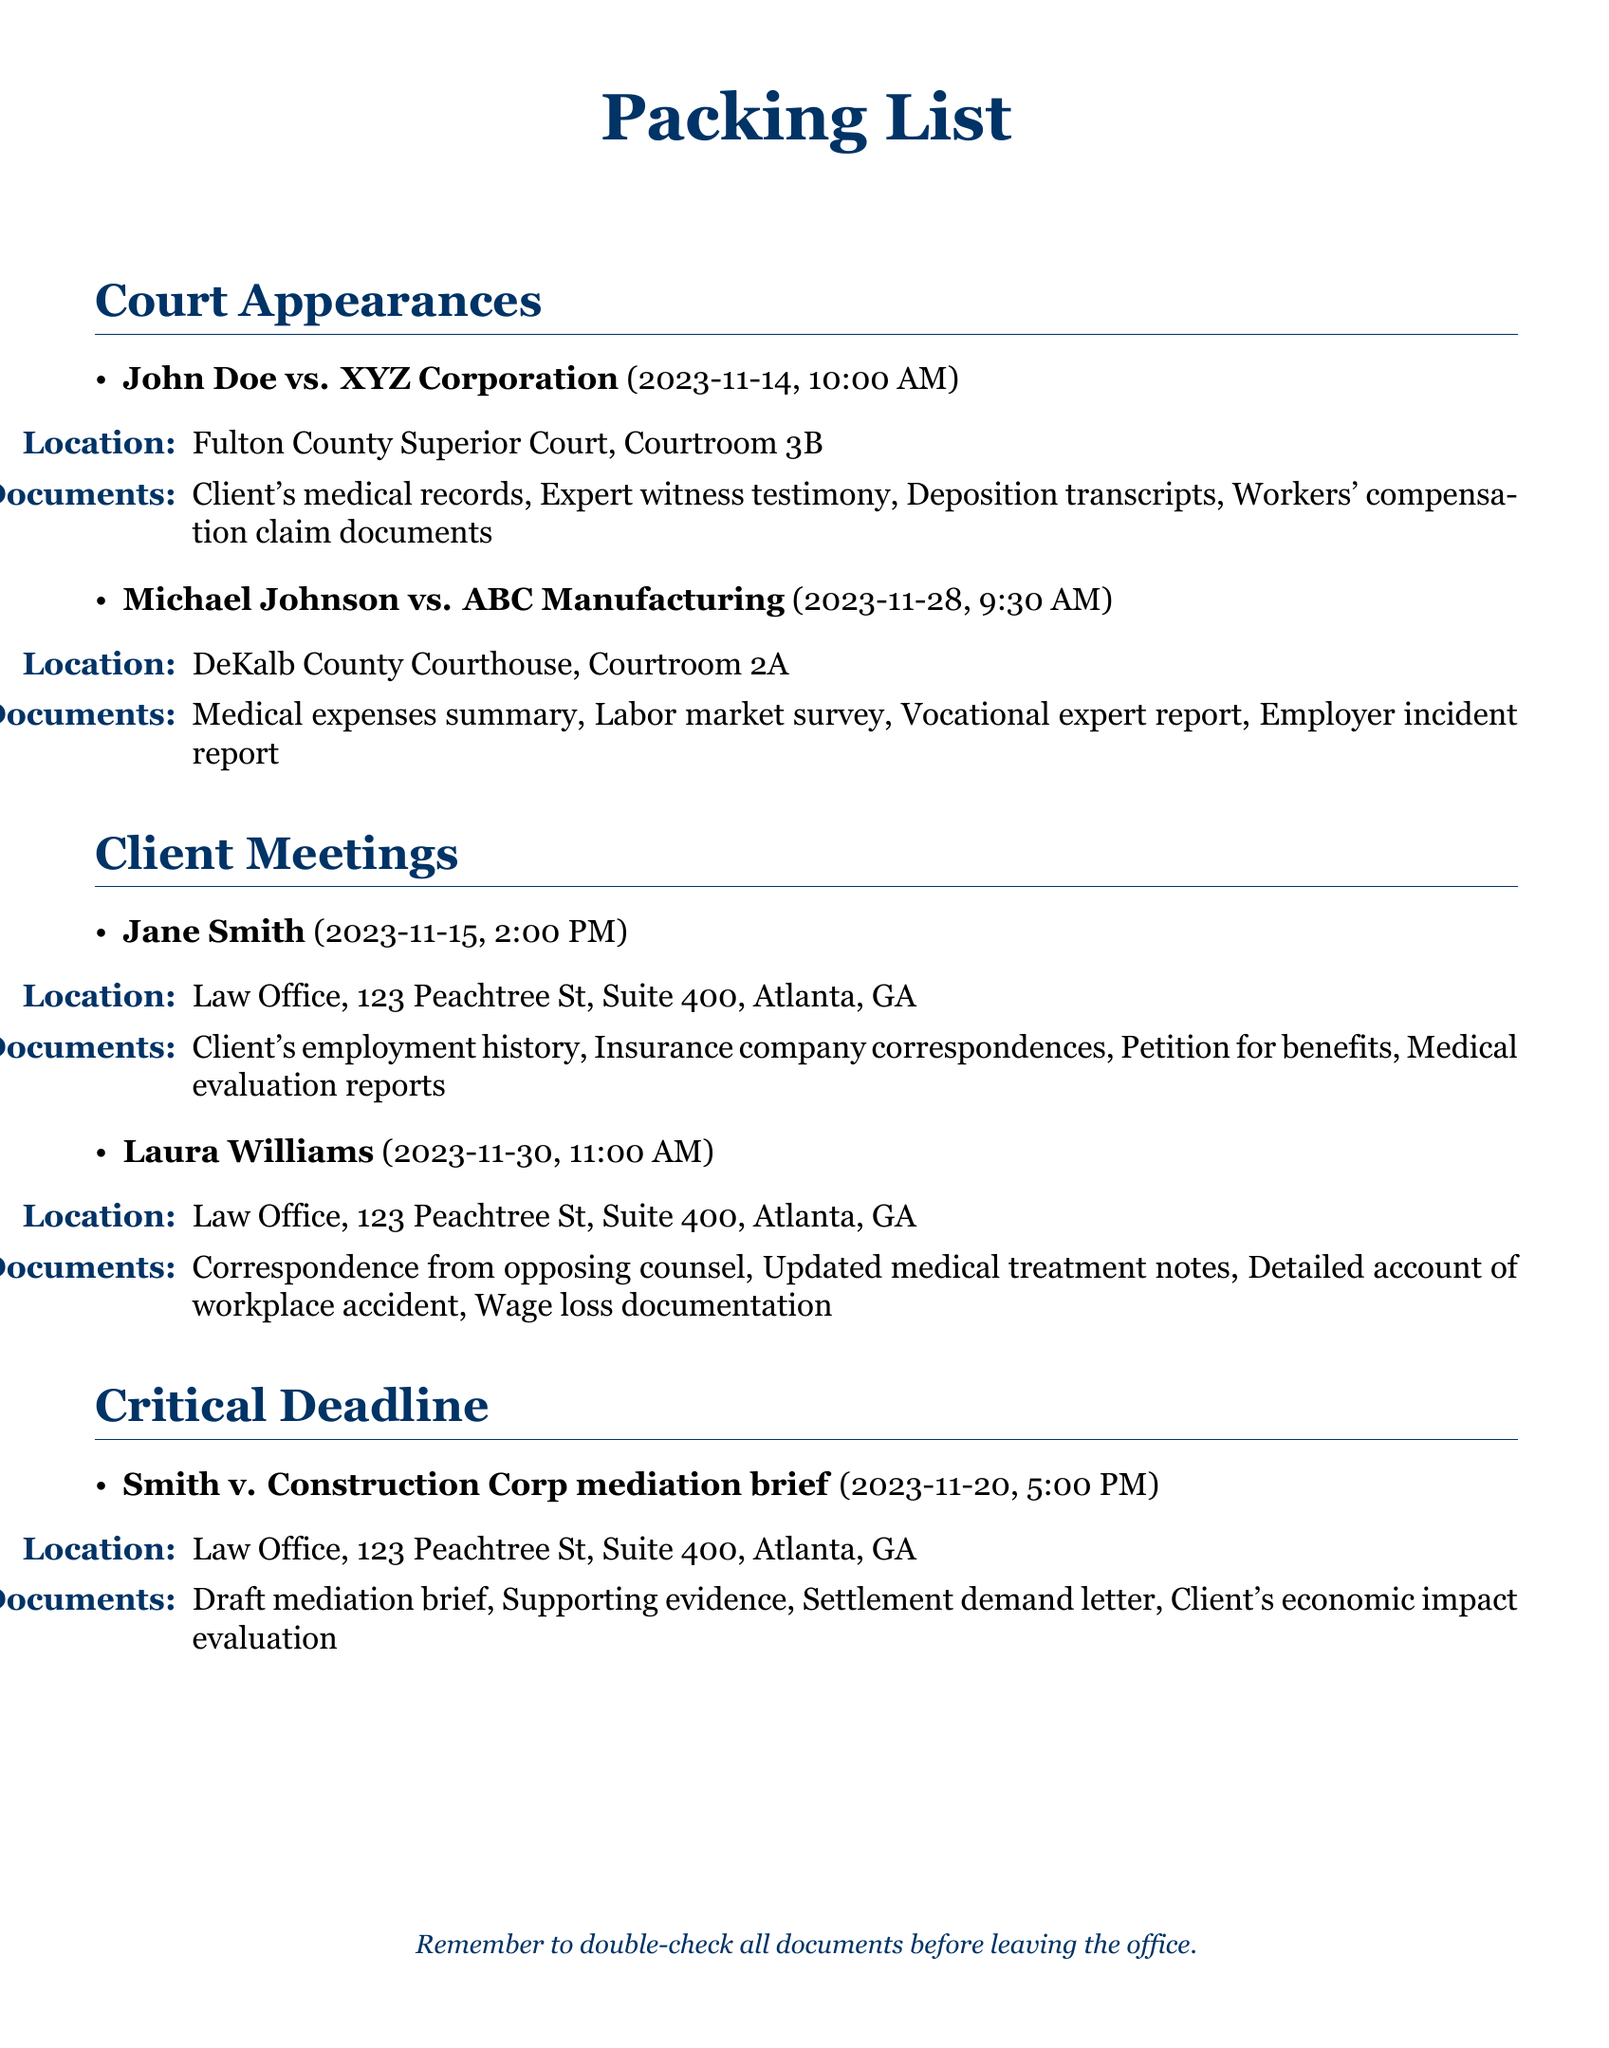What is the court date for John Doe vs. XYZ Corporation? The court date is specified in the document as 2023-11-14.
Answer: 2023-11-14 What time is the hearing for Michael Johnson vs. ABC Manufacturing? The document states the hearing time as 9:30 AM.
Answer: 9:30 AM Where is the meeting with Jane Smith scheduled? The meeting location can be found in the document as the Law Office, 123 Peachtree St, Suite 400, Atlanta, GA.
Answer: Law Office, 123 Peachtree St, Suite 400, Atlanta, GA What document is needed for the mediation brief for Smith v. Construction Corp? The document lists the draft mediation brief as one of the required documents.
Answer: Draft mediation brief Which client meeting occurs closest to the critical deadline? Jane Smith's meeting on 2023-11-15 is closest to the critical deadline on 2023-11-20.
Answer: Jane Smith How many court appearances are listed in the document? The number of court appearances can be calculated from the list; there are two.
Answer: 2 What is the deadline time for the mediation brief? The document specifies the deadline time as 5:00 PM.
Answer: 5:00 PM Which courtroom will the hearing for John Doe vs. XYZ Corporation take place in? The courtroom is mentioned as Courtroom 3B in the document.
Answer: Courtroom 3B 